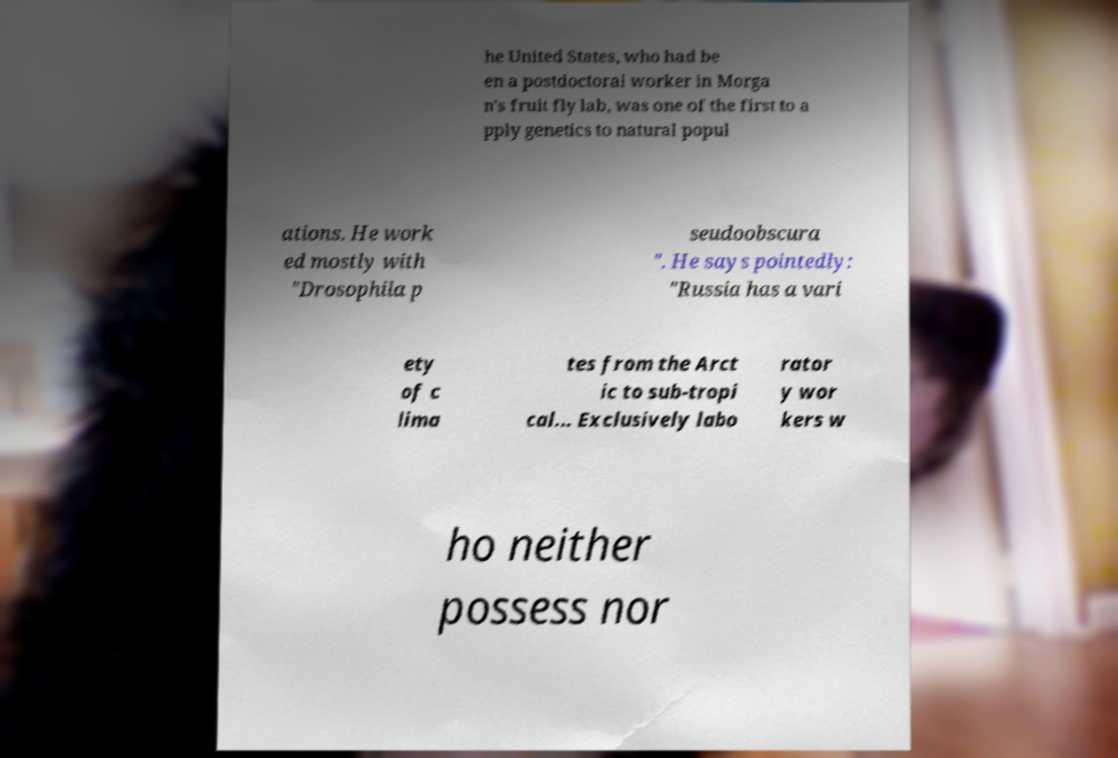Please identify and transcribe the text found in this image. he United States, who had be en a postdoctoral worker in Morga n's fruit fly lab, was one of the first to a pply genetics to natural popul ations. He work ed mostly with "Drosophila p seudoobscura ". He says pointedly: "Russia has a vari ety of c lima tes from the Arct ic to sub-tropi cal... Exclusively labo rator y wor kers w ho neither possess nor 